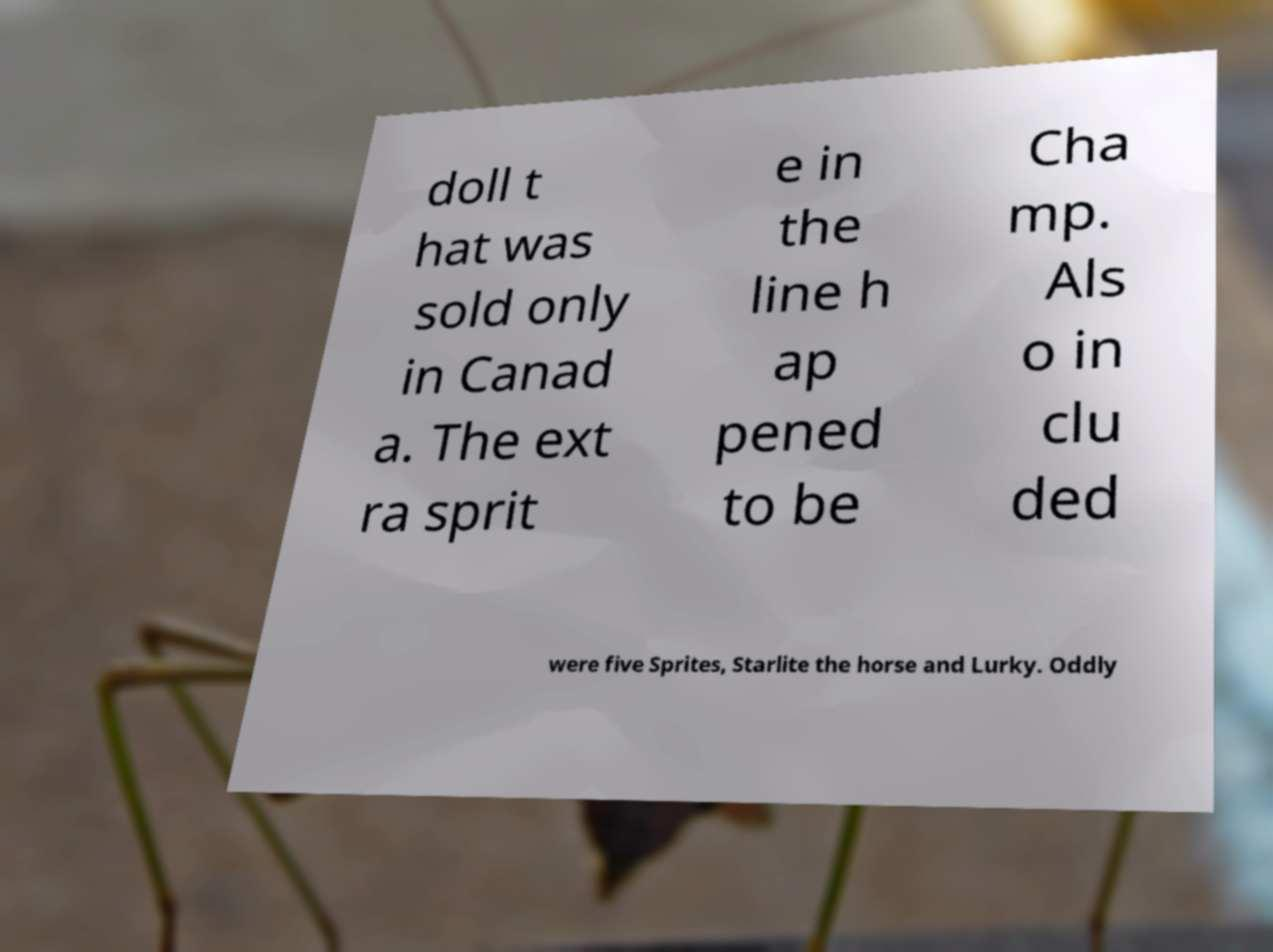There's text embedded in this image that I need extracted. Can you transcribe it verbatim? doll t hat was sold only in Canad a. The ext ra sprit e in the line h ap pened to be Cha mp. Als o in clu ded were five Sprites, Starlite the horse and Lurky. Oddly 